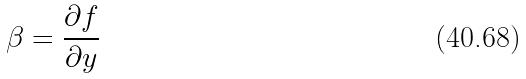<formula> <loc_0><loc_0><loc_500><loc_500>\beta = \frac { \partial f } { \partial y }</formula> 